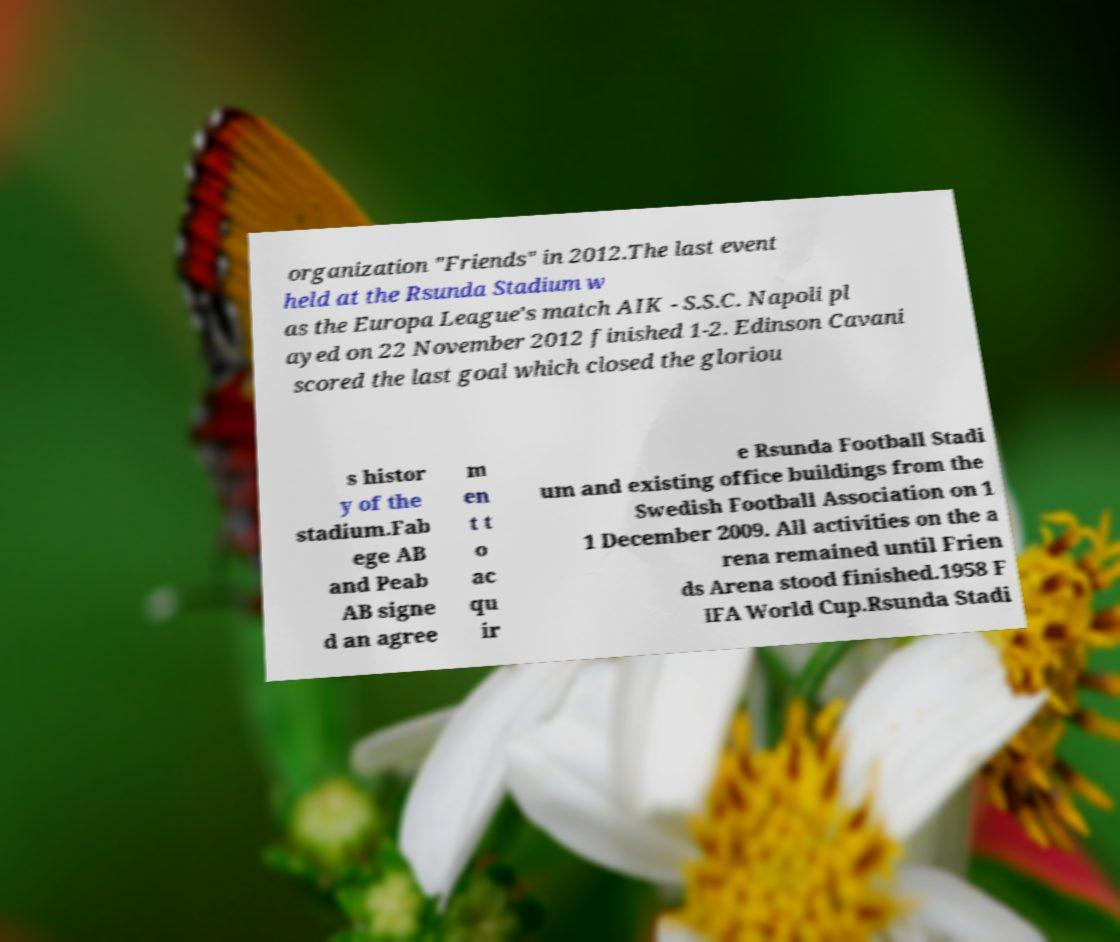Can you read and provide the text displayed in the image?This photo seems to have some interesting text. Can you extract and type it out for me? organization "Friends" in 2012.The last event held at the Rsunda Stadium w as the Europa League's match AIK - S.S.C. Napoli pl ayed on 22 November 2012 finished 1-2. Edinson Cavani scored the last goal which closed the gloriou s histor y of the stadium.Fab ege AB and Peab AB signe d an agree m en t t o ac qu ir e Rsunda Football Stadi um and existing office buildings from the Swedish Football Association on 1 1 December 2009. All activities on the a rena remained until Frien ds Arena stood finished.1958 F IFA World Cup.Rsunda Stadi 